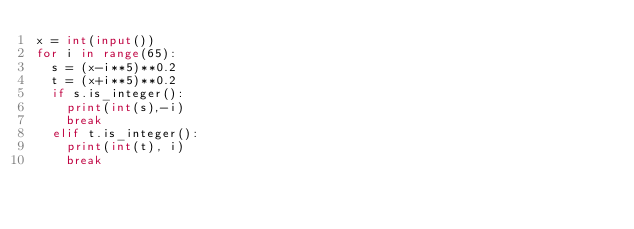<code> <loc_0><loc_0><loc_500><loc_500><_Python_>x = int(input())
for i in range(65):
  s = (x-i**5)**0.2
  t = (x+i**5)**0.2
  if s.is_integer():
    print(int(s),-i)
    break
  elif t.is_integer():
    print(int(t), i)
    break</code> 